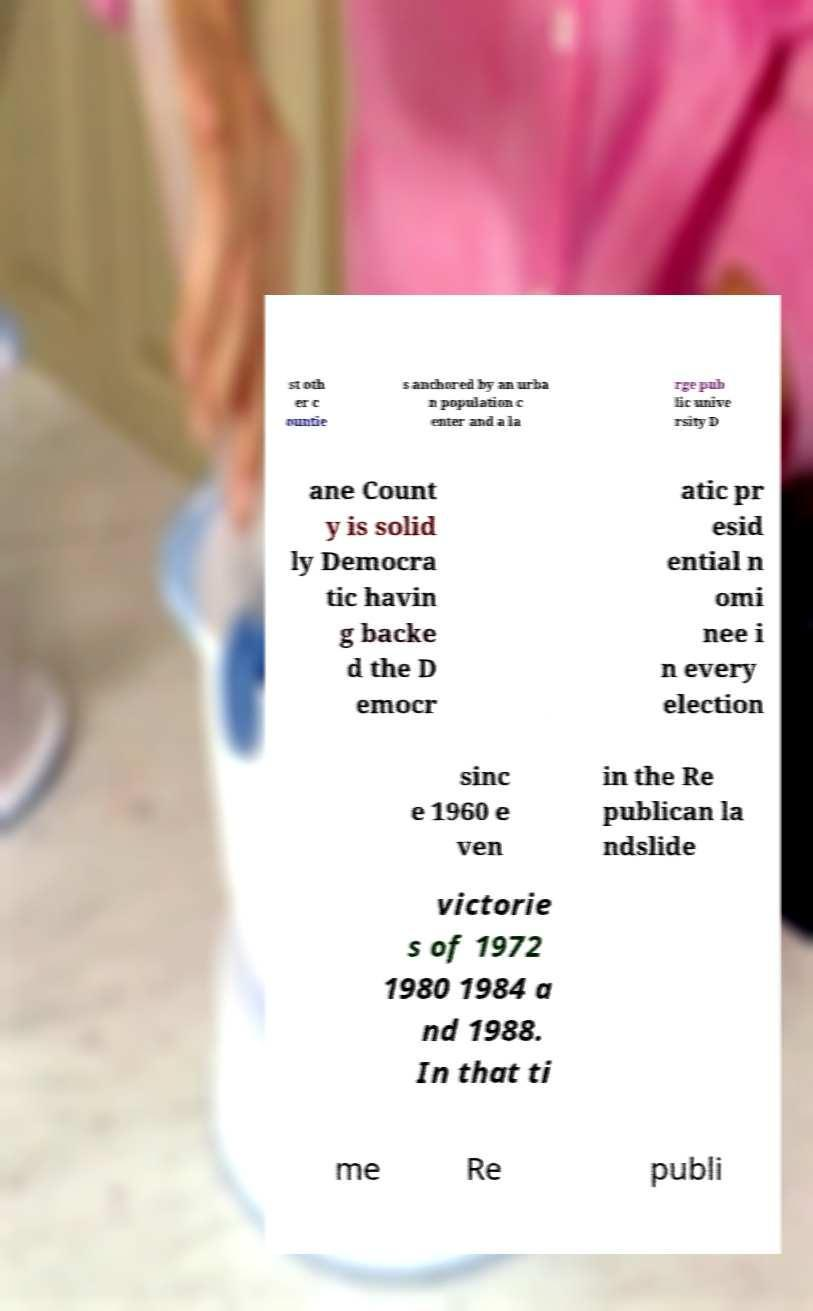For documentation purposes, I need the text within this image transcribed. Could you provide that? st oth er c ountie s anchored by an urba n population c enter and a la rge pub lic unive rsity D ane Count y is solid ly Democra tic havin g backe d the D emocr atic pr esid ential n omi nee i n every election sinc e 1960 e ven in the Re publican la ndslide victorie s of 1972 1980 1984 a nd 1988. In that ti me Re publi 